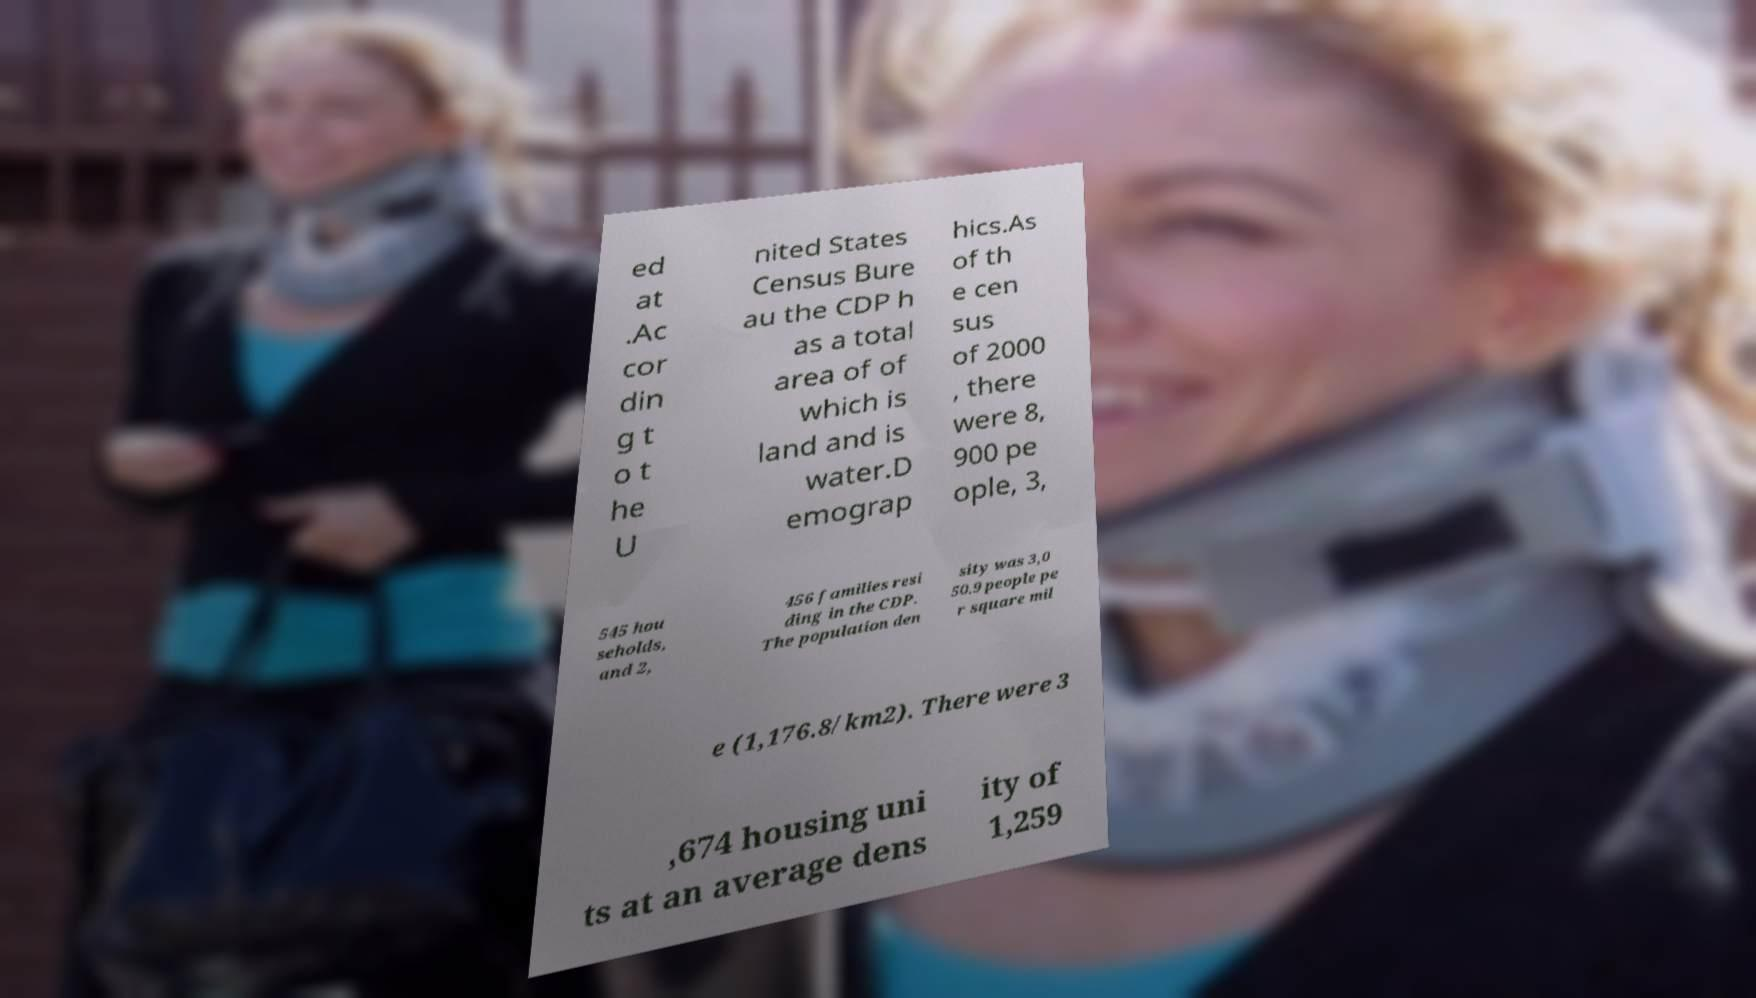Can you accurately transcribe the text from the provided image for me? ed at .Ac cor din g t o t he U nited States Census Bure au the CDP h as a total area of of which is land and is water.D emograp hics.As of th e cen sus of 2000 , there were 8, 900 pe ople, 3, 545 hou seholds, and 2, 456 families resi ding in the CDP. The population den sity was 3,0 50.9 people pe r square mil e (1,176.8/km2). There were 3 ,674 housing uni ts at an average dens ity of 1,259 